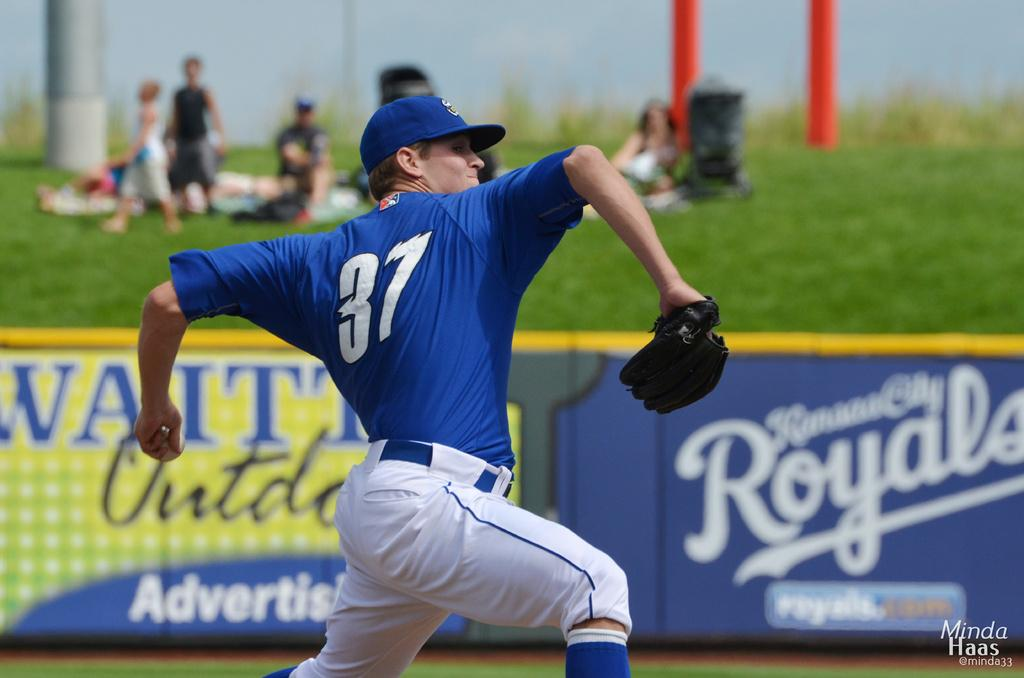<image>
Present a compact description of the photo's key features. A pitcher wearing the number 37 gets ready to throw a baseball. 